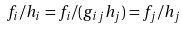<formula> <loc_0><loc_0><loc_500><loc_500>f _ { i } / h _ { i } = f _ { i } / ( g _ { i j } h _ { j } ) = f _ { j } / h _ { j }</formula> 